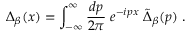Convert formula to latex. <formula><loc_0><loc_0><loc_500><loc_500>\Delta _ { \beta } ( x ) = \int _ { - \infty } ^ { \infty } { \frac { d p } { 2 \pi } } \, e ^ { - i p x } \, \tilde { \Delta } _ { \beta } ( p ) \, .</formula> 